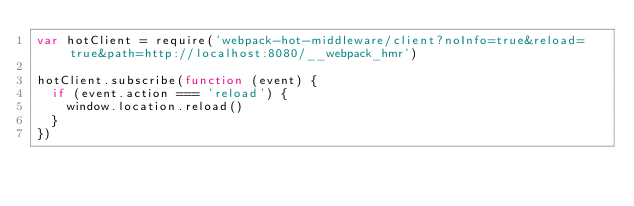Convert code to text. <code><loc_0><loc_0><loc_500><loc_500><_JavaScript_>var hotClient = require('webpack-hot-middleware/client?noInfo=true&reload=true&path=http://localhost:8080/__webpack_hmr')

hotClient.subscribe(function (event) {
  if (event.action === 'reload') {
    window.location.reload()
  }
})
</code> 